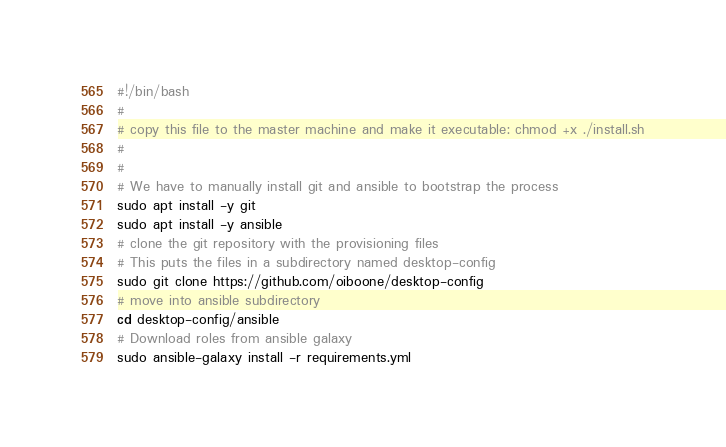<code> <loc_0><loc_0><loc_500><loc_500><_Bash_>#!/bin/bash
#
# copy this file to the master machine and make it executable: chmod +x ./install.sh
# 
#
# We have to manually install git and ansible to bootstrap the process
sudo apt install -y git
sudo apt install -y ansible
# clone the git repository with the provisioning files
# This puts the files in a subdirectory named desktop-config
sudo git clone https://github.com/oiboone/desktop-config
# move into ansible subdirectory
cd desktop-config/ansible
# Download roles from ansible galaxy
sudo ansible-galaxy install -r requirements.yml
</code> 